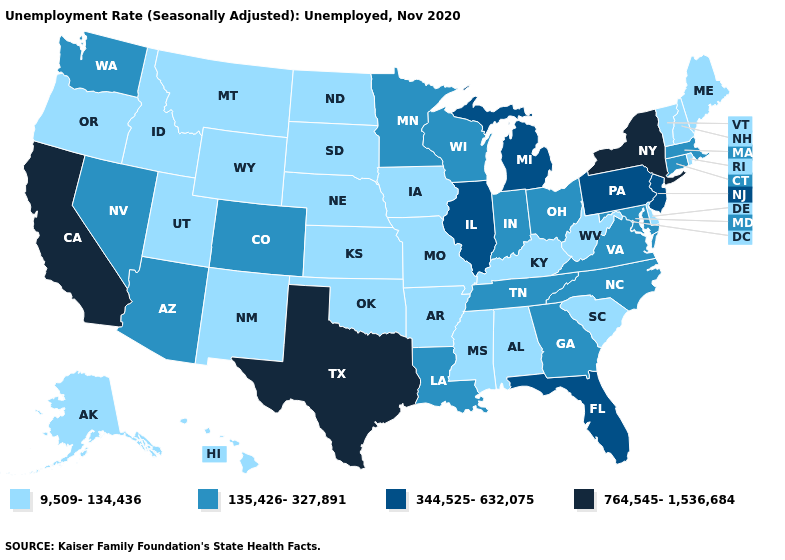Name the states that have a value in the range 135,426-327,891?
Be succinct. Arizona, Colorado, Connecticut, Georgia, Indiana, Louisiana, Maryland, Massachusetts, Minnesota, Nevada, North Carolina, Ohio, Tennessee, Virginia, Washington, Wisconsin. Name the states that have a value in the range 9,509-134,436?
Give a very brief answer. Alabama, Alaska, Arkansas, Delaware, Hawaii, Idaho, Iowa, Kansas, Kentucky, Maine, Mississippi, Missouri, Montana, Nebraska, New Hampshire, New Mexico, North Dakota, Oklahoma, Oregon, Rhode Island, South Carolina, South Dakota, Utah, Vermont, West Virginia, Wyoming. What is the value of Indiana?
Give a very brief answer. 135,426-327,891. Name the states that have a value in the range 764,545-1,536,684?
Give a very brief answer. California, New York, Texas. Name the states that have a value in the range 344,525-632,075?
Short answer required. Florida, Illinois, Michigan, New Jersey, Pennsylvania. What is the highest value in the USA?
Short answer required. 764,545-1,536,684. What is the value of Nevada?
Be succinct. 135,426-327,891. What is the highest value in states that border Maryland?
Concise answer only. 344,525-632,075. What is the value of Georgia?
Be succinct. 135,426-327,891. Does New York have the highest value in the Northeast?
Concise answer only. Yes. Name the states that have a value in the range 344,525-632,075?
Short answer required. Florida, Illinois, Michigan, New Jersey, Pennsylvania. Does the map have missing data?
Keep it brief. No. Name the states that have a value in the range 9,509-134,436?
Concise answer only. Alabama, Alaska, Arkansas, Delaware, Hawaii, Idaho, Iowa, Kansas, Kentucky, Maine, Mississippi, Missouri, Montana, Nebraska, New Hampshire, New Mexico, North Dakota, Oklahoma, Oregon, Rhode Island, South Carolina, South Dakota, Utah, Vermont, West Virginia, Wyoming. What is the value of Massachusetts?
Quick response, please. 135,426-327,891. Among the states that border Missouri , which have the highest value?
Give a very brief answer. Illinois. 